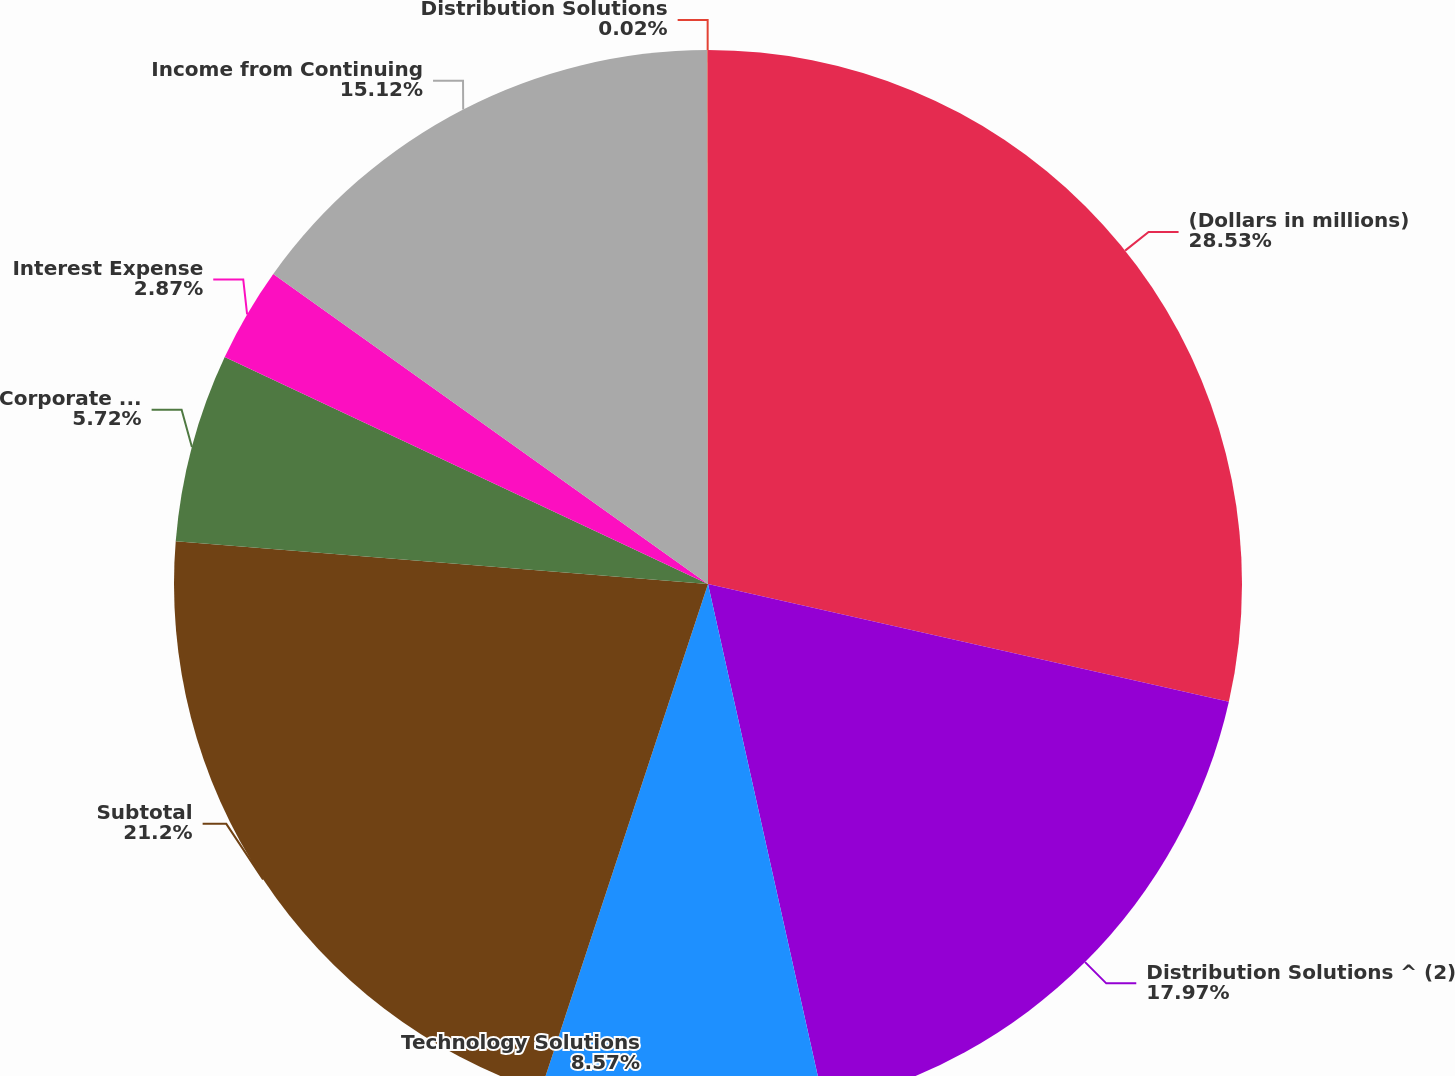Convert chart to OTSL. <chart><loc_0><loc_0><loc_500><loc_500><pie_chart><fcel>(Dollars in millions)<fcel>Distribution Solutions ^ (2)<fcel>Technology Solutions<fcel>Subtotal<fcel>Corporate Expenses Net<fcel>Interest Expense<fcel>Income from Continuing<fcel>Distribution Solutions<nl><fcel>28.54%<fcel>17.97%<fcel>8.57%<fcel>21.2%<fcel>5.72%<fcel>2.87%<fcel>15.12%<fcel>0.02%<nl></chart> 